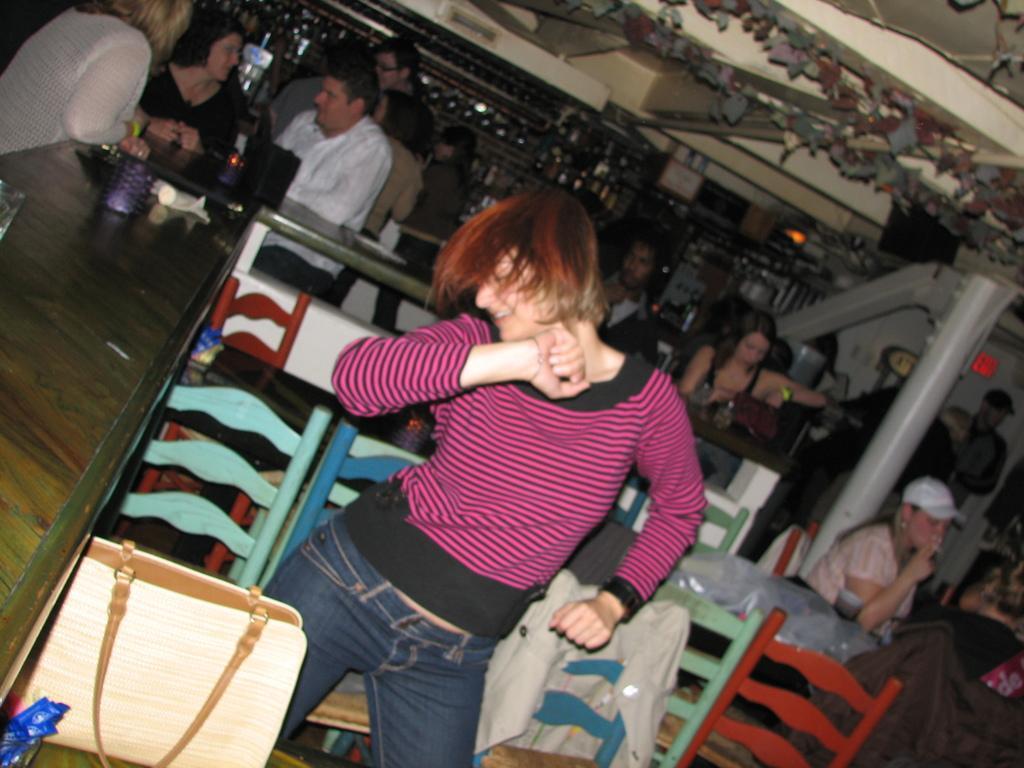In one or two sentences, can you explain what this image depicts? In this image we can see a woman is dancing. She is wearing a T-shirt and jeans. In the background, we can see tables, chairs, people, pole, racks and roof. There is a bag in the left bottom of the image. We can see so many objects on the table. 